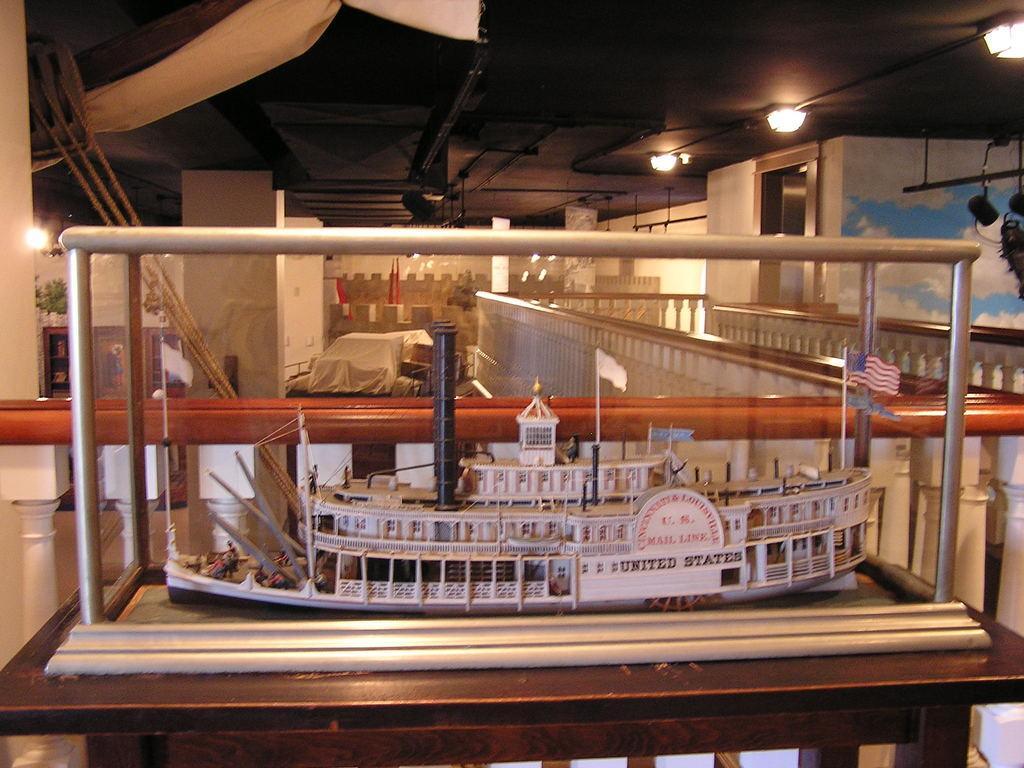How would you summarize this image in a sentence or two? In the center of the image we can see a toy ship placed in the box. At the bottom there is a table. In the background there is a cloth, ropes, walls, door and lights. 